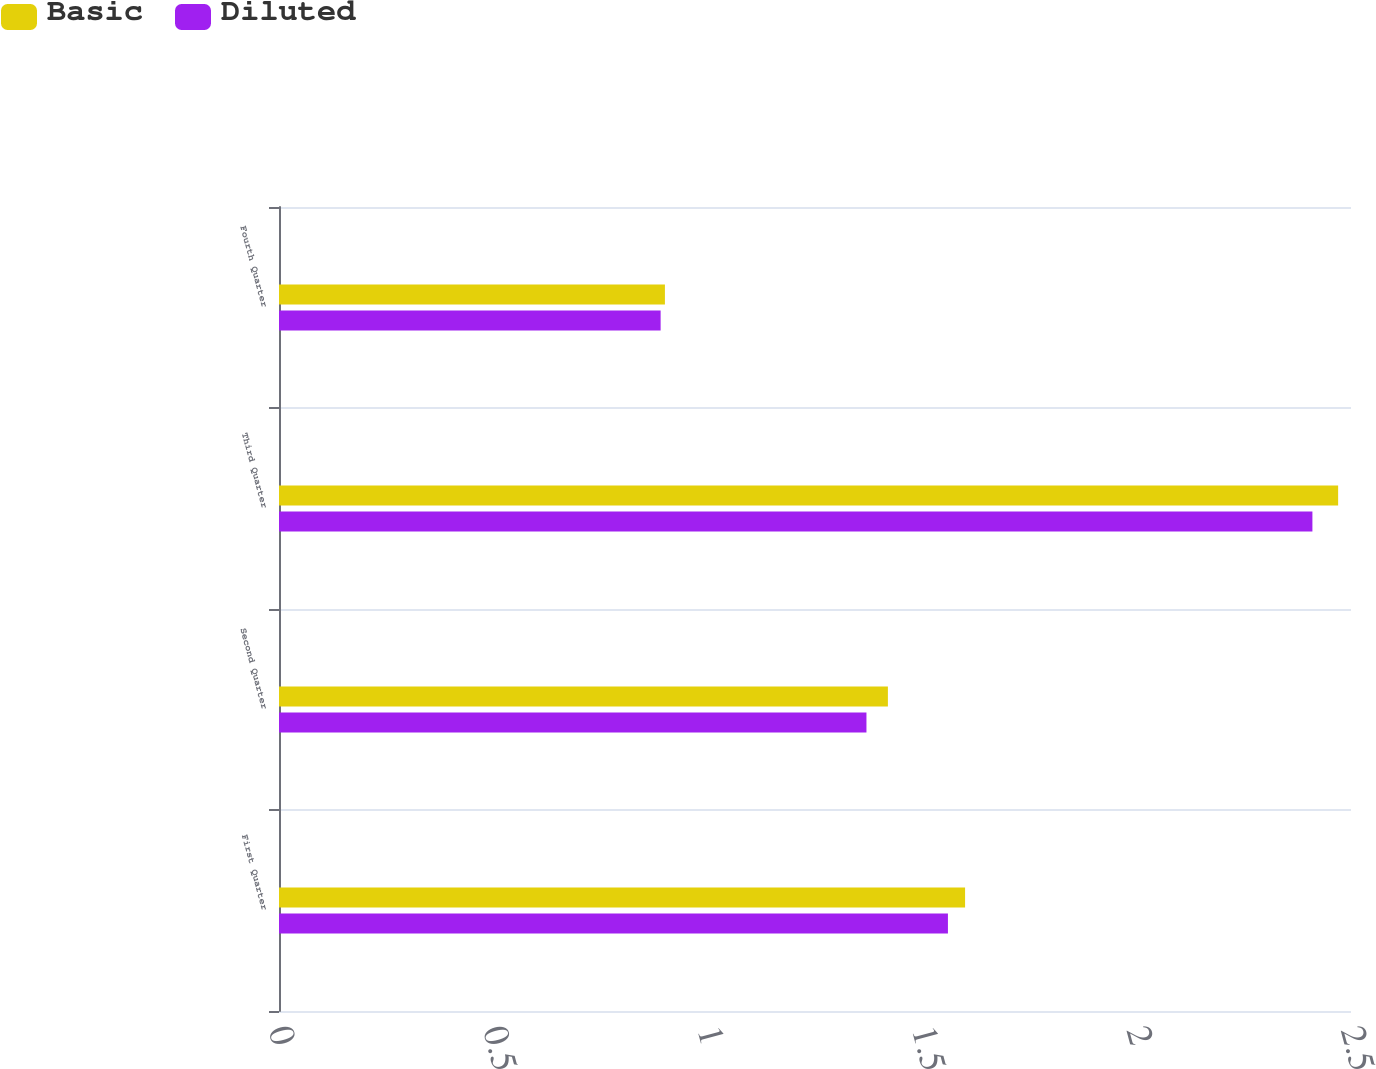Convert chart. <chart><loc_0><loc_0><loc_500><loc_500><stacked_bar_chart><ecel><fcel>First Quarter<fcel>Second Quarter<fcel>Third Quarter<fcel>Fourth Quarter<nl><fcel>Basic<fcel>1.6<fcel>1.42<fcel>2.47<fcel>0.9<nl><fcel>Diluted<fcel>1.56<fcel>1.37<fcel>2.41<fcel>0.89<nl></chart> 